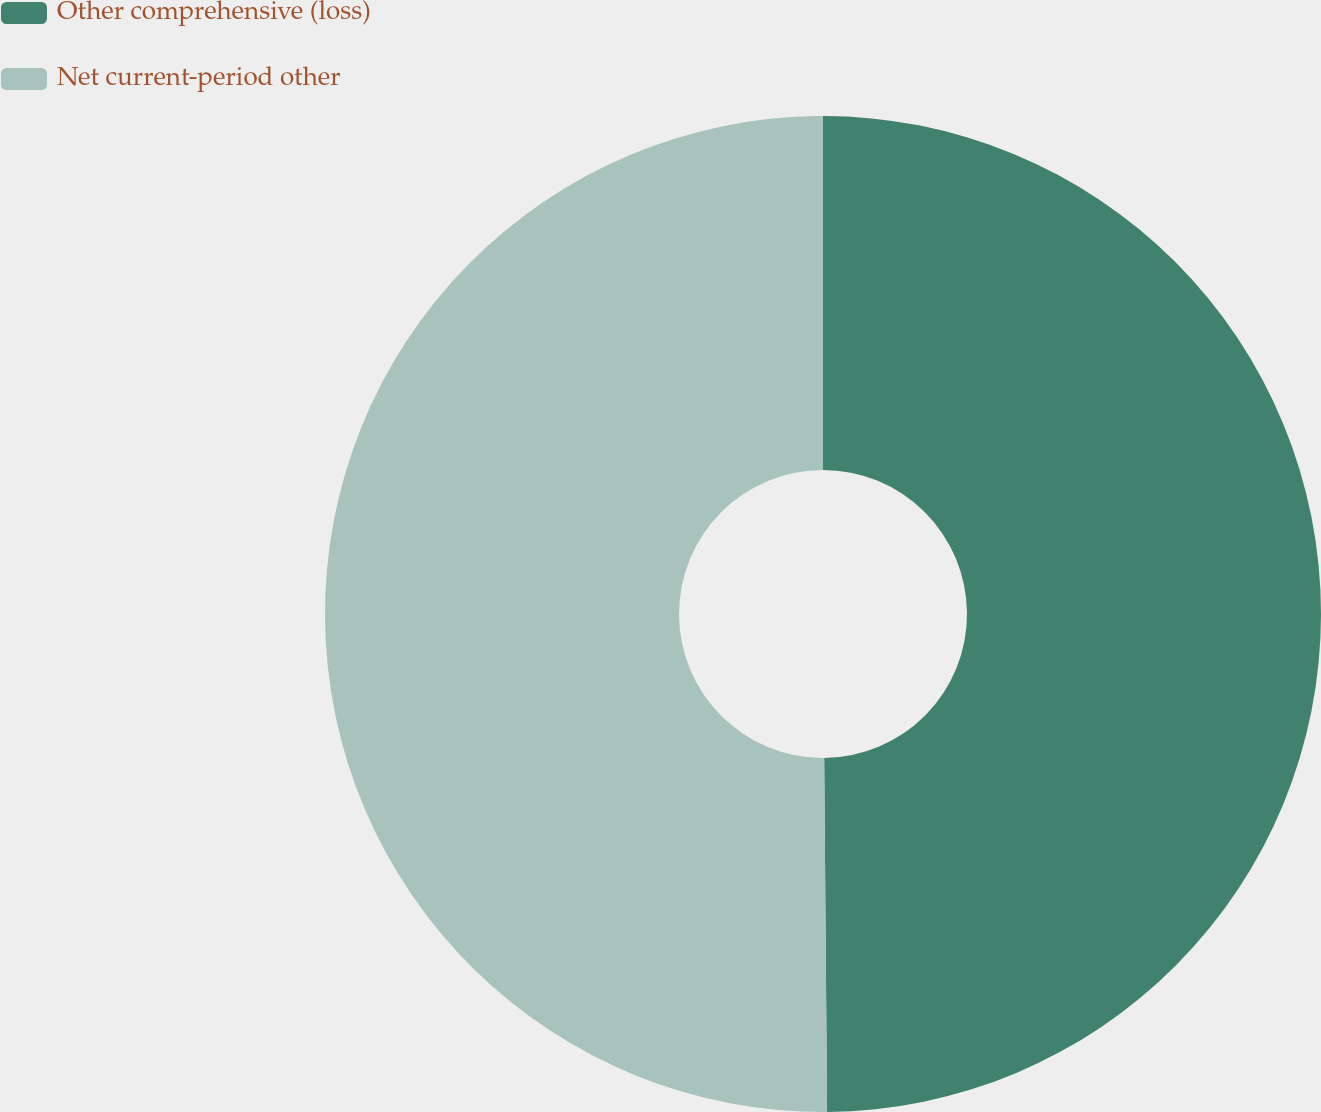Convert chart to OTSL. <chart><loc_0><loc_0><loc_500><loc_500><pie_chart><fcel>Other comprehensive (loss)<fcel>Net current-period other<nl><fcel>49.87%<fcel>50.13%<nl></chart> 